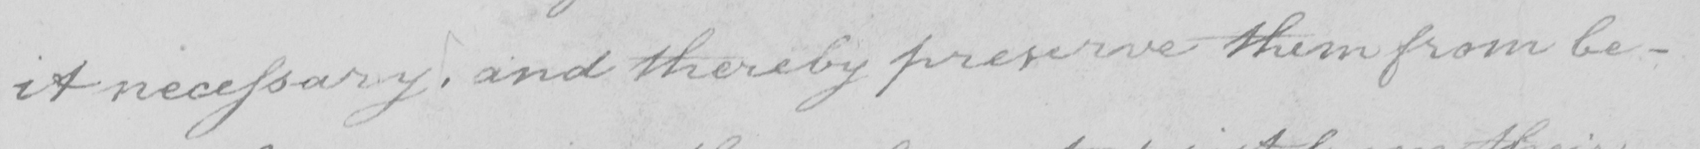Transcribe the text shown in this historical manuscript line. it necessary , and thereby preserve them from be- 